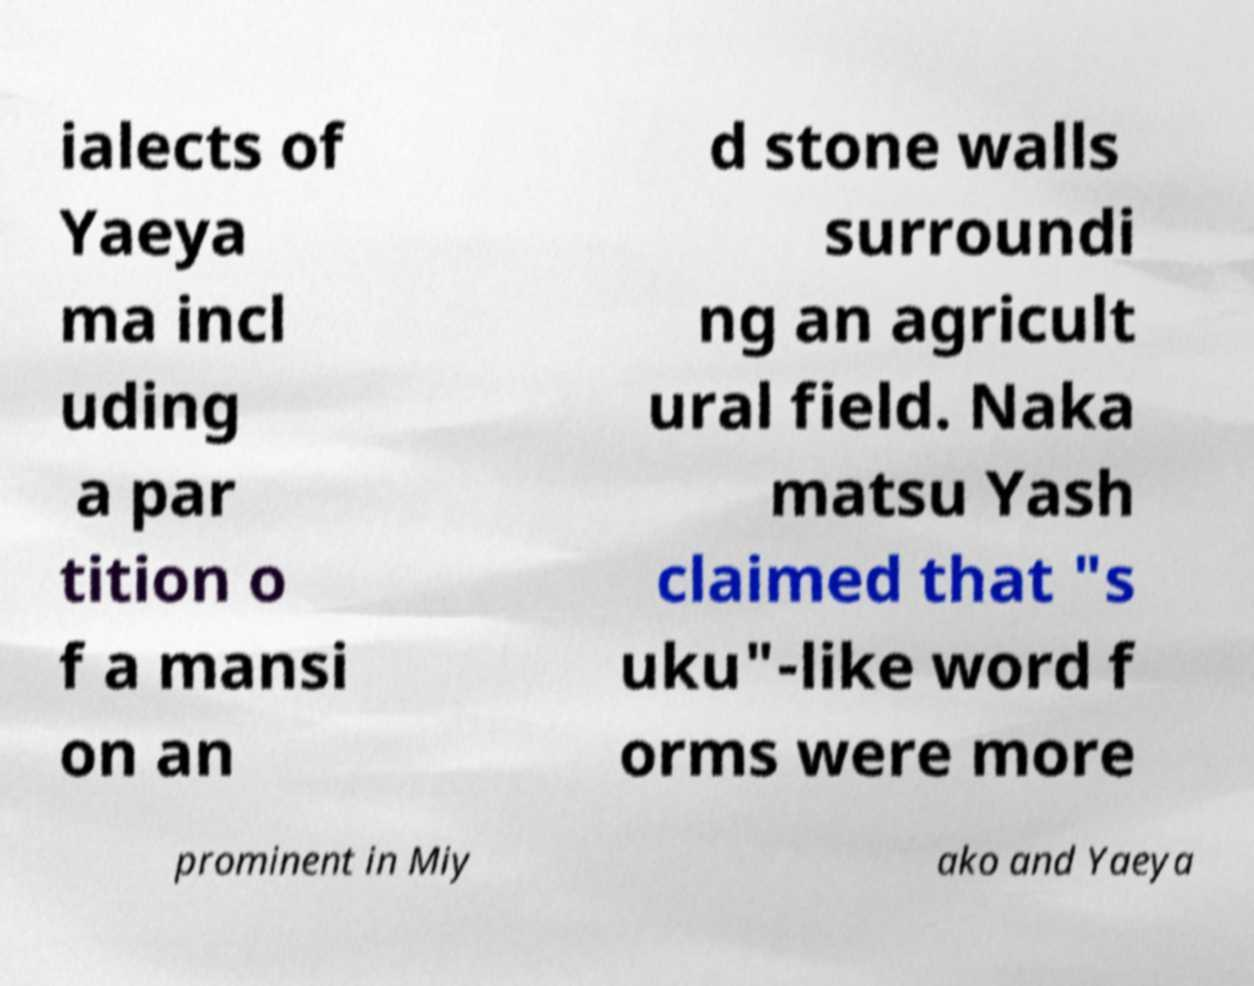What messages or text are displayed in this image? I need them in a readable, typed format. ialects of Yaeya ma incl uding a par tition o f a mansi on an d stone walls surroundi ng an agricult ural field. Naka matsu Yash claimed that "s uku"-like word f orms were more prominent in Miy ako and Yaeya 